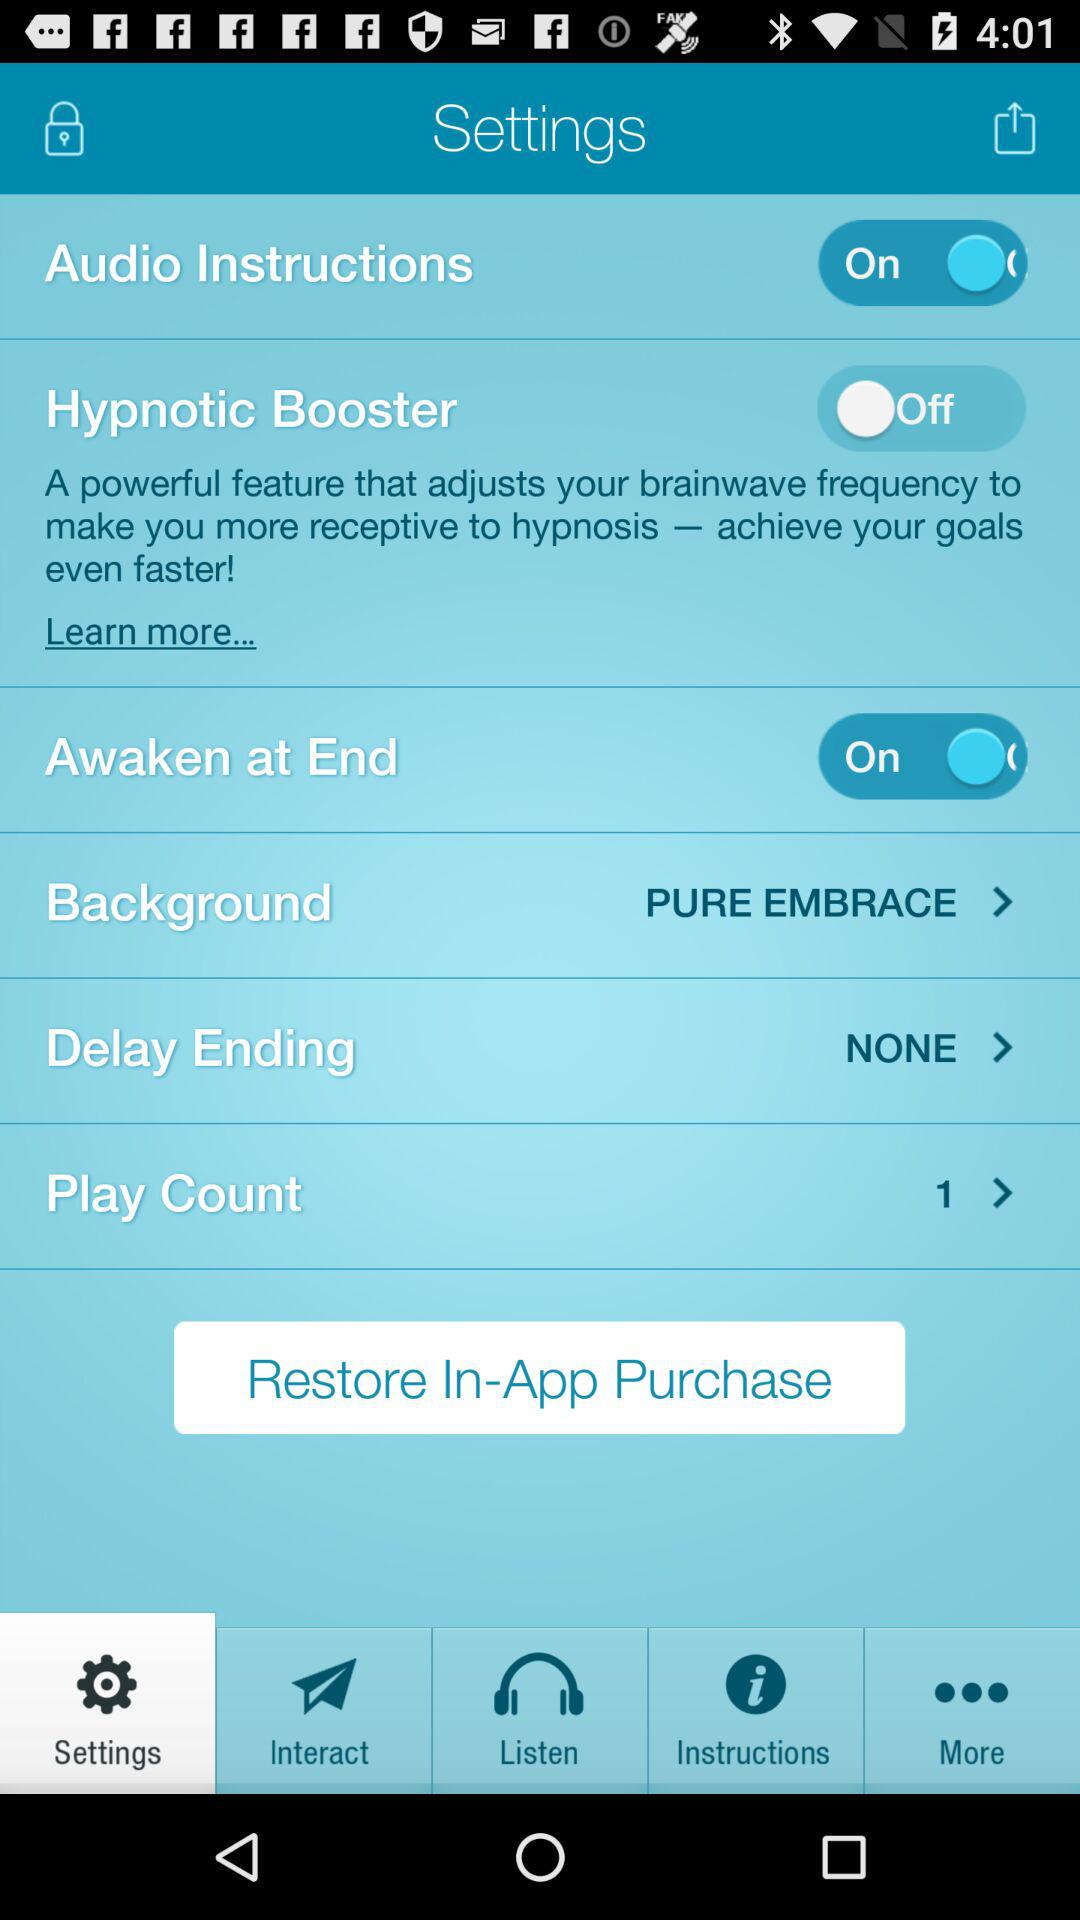What is the current status of "Audio Instructions"? The status is "on". 